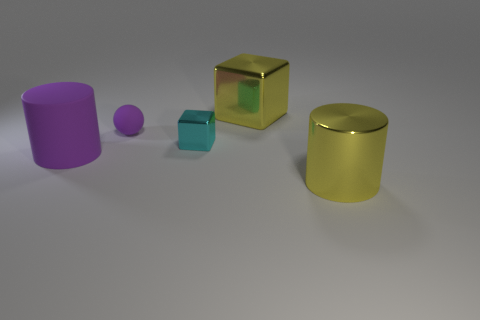What size is the matte thing behind the big object left of the small thing that is in front of the tiny rubber thing?
Ensure brevity in your answer.  Small. How many other objects are the same color as the large shiny cylinder?
Your answer should be compact. 1. The purple object that is the same size as the cyan cube is what shape?
Your answer should be very brief. Sphere. There is a yellow object in front of the large purple matte cylinder; how big is it?
Provide a short and direct response. Large. Is the color of the small object to the left of the cyan shiny object the same as the matte thing in front of the cyan metallic block?
Ensure brevity in your answer.  Yes. What is the material of the big object that is to the right of the metal object behind the small purple ball that is behind the tiny cyan thing?
Your answer should be compact. Metal. Are there any yellow shiny cubes that have the same size as the purple cylinder?
Keep it short and to the point. Yes. There is a purple sphere that is the same size as the cyan object; what is it made of?
Your response must be concise. Rubber. There is a large yellow metal thing in front of the small cube; what is its shape?
Ensure brevity in your answer.  Cylinder. Is the tiny object that is to the right of the purple sphere made of the same material as the cylinder right of the tiny sphere?
Your answer should be very brief. Yes. 